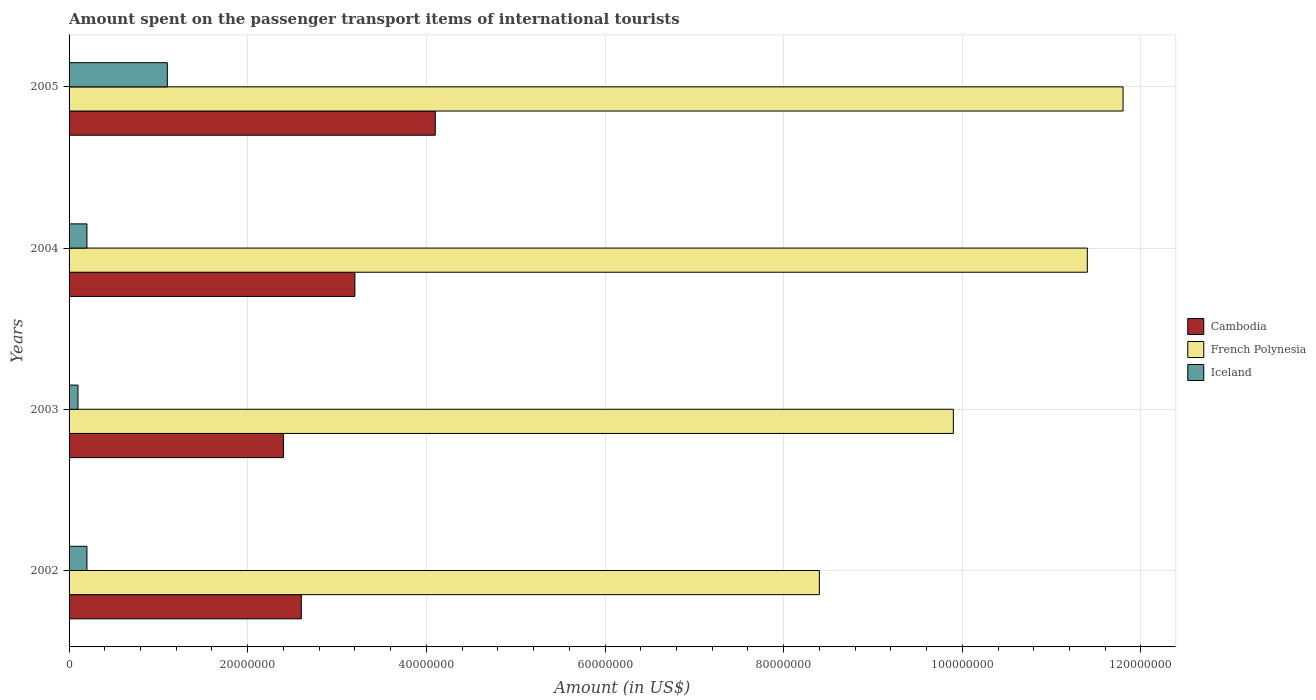How many different coloured bars are there?
Provide a short and direct response. 3. How many groups of bars are there?
Your response must be concise. 4. Are the number of bars per tick equal to the number of legend labels?
Offer a terse response. Yes. Are the number of bars on each tick of the Y-axis equal?
Ensure brevity in your answer.  Yes. In how many cases, is the number of bars for a given year not equal to the number of legend labels?
Ensure brevity in your answer.  0. What is the amount spent on the passenger transport items of international tourists in French Polynesia in 2002?
Give a very brief answer. 8.40e+07. Across all years, what is the maximum amount spent on the passenger transport items of international tourists in French Polynesia?
Provide a succinct answer. 1.18e+08. Across all years, what is the minimum amount spent on the passenger transport items of international tourists in Cambodia?
Ensure brevity in your answer.  2.40e+07. In which year was the amount spent on the passenger transport items of international tourists in French Polynesia minimum?
Your answer should be very brief. 2002. What is the total amount spent on the passenger transport items of international tourists in French Polynesia in the graph?
Your response must be concise. 4.15e+08. What is the difference between the amount spent on the passenger transport items of international tourists in Cambodia in 2002 and that in 2005?
Make the answer very short. -1.50e+07. What is the difference between the amount spent on the passenger transport items of international tourists in Iceland in 2003 and the amount spent on the passenger transport items of international tourists in French Polynesia in 2002?
Offer a terse response. -8.30e+07. What is the average amount spent on the passenger transport items of international tourists in French Polynesia per year?
Provide a succinct answer. 1.04e+08. In the year 2005, what is the difference between the amount spent on the passenger transport items of international tourists in Iceland and amount spent on the passenger transport items of international tourists in Cambodia?
Your response must be concise. -3.00e+07. What is the ratio of the amount spent on the passenger transport items of international tourists in French Polynesia in 2002 to that in 2003?
Keep it short and to the point. 0.85. What is the difference between the highest and the second highest amount spent on the passenger transport items of international tourists in Iceland?
Make the answer very short. 9.00e+06. What is the difference between the highest and the lowest amount spent on the passenger transport items of international tourists in Iceland?
Offer a very short reply. 1.00e+07. What does the 2nd bar from the top in 2003 represents?
Provide a succinct answer. French Polynesia. What does the 1st bar from the bottom in 2004 represents?
Ensure brevity in your answer.  Cambodia. Is it the case that in every year, the sum of the amount spent on the passenger transport items of international tourists in Iceland and amount spent on the passenger transport items of international tourists in Cambodia is greater than the amount spent on the passenger transport items of international tourists in French Polynesia?
Provide a succinct answer. No. Are all the bars in the graph horizontal?
Your answer should be compact. Yes. How many years are there in the graph?
Your response must be concise. 4. What is the difference between two consecutive major ticks on the X-axis?
Your answer should be very brief. 2.00e+07. Are the values on the major ticks of X-axis written in scientific E-notation?
Offer a terse response. No. Does the graph contain grids?
Give a very brief answer. Yes. Where does the legend appear in the graph?
Offer a very short reply. Center right. How are the legend labels stacked?
Offer a very short reply. Vertical. What is the title of the graph?
Offer a very short reply. Amount spent on the passenger transport items of international tourists. Does "India" appear as one of the legend labels in the graph?
Make the answer very short. No. What is the label or title of the X-axis?
Give a very brief answer. Amount (in US$). What is the label or title of the Y-axis?
Give a very brief answer. Years. What is the Amount (in US$) in Cambodia in 2002?
Provide a short and direct response. 2.60e+07. What is the Amount (in US$) of French Polynesia in 2002?
Make the answer very short. 8.40e+07. What is the Amount (in US$) in Cambodia in 2003?
Make the answer very short. 2.40e+07. What is the Amount (in US$) in French Polynesia in 2003?
Provide a short and direct response. 9.90e+07. What is the Amount (in US$) of Cambodia in 2004?
Provide a succinct answer. 3.20e+07. What is the Amount (in US$) of French Polynesia in 2004?
Give a very brief answer. 1.14e+08. What is the Amount (in US$) of Iceland in 2004?
Give a very brief answer. 2.00e+06. What is the Amount (in US$) in Cambodia in 2005?
Ensure brevity in your answer.  4.10e+07. What is the Amount (in US$) of French Polynesia in 2005?
Make the answer very short. 1.18e+08. What is the Amount (in US$) of Iceland in 2005?
Your answer should be very brief. 1.10e+07. Across all years, what is the maximum Amount (in US$) of Cambodia?
Ensure brevity in your answer.  4.10e+07. Across all years, what is the maximum Amount (in US$) of French Polynesia?
Offer a very short reply. 1.18e+08. Across all years, what is the maximum Amount (in US$) in Iceland?
Your response must be concise. 1.10e+07. Across all years, what is the minimum Amount (in US$) of Cambodia?
Provide a succinct answer. 2.40e+07. Across all years, what is the minimum Amount (in US$) in French Polynesia?
Provide a short and direct response. 8.40e+07. Across all years, what is the minimum Amount (in US$) of Iceland?
Give a very brief answer. 1.00e+06. What is the total Amount (in US$) of Cambodia in the graph?
Offer a very short reply. 1.23e+08. What is the total Amount (in US$) of French Polynesia in the graph?
Offer a very short reply. 4.15e+08. What is the total Amount (in US$) in Iceland in the graph?
Make the answer very short. 1.60e+07. What is the difference between the Amount (in US$) of French Polynesia in 2002 and that in 2003?
Your answer should be very brief. -1.50e+07. What is the difference between the Amount (in US$) in Cambodia in 2002 and that in 2004?
Offer a very short reply. -6.00e+06. What is the difference between the Amount (in US$) in French Polynesia in 2002 and that in 2004?
Provide a short and direct response. -3.00e+07. What is the difference between the Amount (in US$) of Iceland in 2002 and that in 2004?
Keep it short and to the point. 0. What is the difference between the Amount (in US$) in Cambodia in 2002 and that in 2005?
Your answer should be very brief. -1.50e+07. What is the difference between the Amount (in US$) of French Polynesia in 2002 and that in 2005?
Your answer should be compact. -3.40e+07. What is the difference between the Amount (in US$) in Iceland in 2002 and that in 2005?
Your answer should be compact. -9.00e+06. What is the difference between the Amount (in US$) of Cambodia in 2003 and that in 2004?
Your answer should be compact. -8.00e+06. What is the difference between the Amount (in US$) of French Polynesia in 2003 and that in 2004?
Offer a very short reply. -1.50e+07. What is the difference between the Amount (in US$) of Iceland in 2003 and that in 2004?
Provide a short and direct response. -1.00e+06. What is the difference between the Amount (in US$) in Cambodia in 2003 and that in 2005?
Your answer should be very brief. -1.70e+07. What is the difference between the Amount (in US$) of French Polynesia in 2003 and that in 2005?
Your response must be concise. -1.90e+07. What is the difference between the Amount (in US$) in Iceland in 2003 and that in 2005?
Offer a terse response. -1.00e+07. What is the difference between the Amount (in US$) of Cambodia in 2004 and that in 2005?
Keep it short and to the point. -9.00e+06. What is the difference between the Amount (in US$) of Iceland in 2004 and that in 2005?
Offer a very short reply. -9.00e+06. What is the difference between the Amount (in US$) of Cambodia in 2002 and the Amount (in US$) of French Polynesia in 2003?
Offer a terse response. -7.30e+07. What is the difference between the Amount (in US$) of Cambodia in 2002 and the Amount (in US$) of Iceland in 2003?
Provide a succinct answer. 2.50e+07. What is the difference between the Amount (in US$) of French Polynesia in 2002 and the Amount (in US$) of Iceland in 2003?
Keep it short and to the point. 8.30e+07. What is the difference between the Amount (in US$) in Cambodia in 2002 and the Amount (in US$) in French Polynesia in 2004?
Offer a very short reply. -8.80e+07. What is the difference between the Amount (in US$) in Cambodia in 2002 and the Amount (in US$) in Iceland in 2004?
Make the answer very short. 2.40e+07. What is the difference between the Amount (in US$) of French Polynesia in 2002 and the Amount (in US$) of Iceland in 2004?
Give a very brief answer. 8.20e+07. What is the difference between the Amount (in US$) in Cambodia in 2002 and the Amount (in US$) in French Polynesia in 2005?
Ensure brevity in your answer.  -9.20e+07. What is the difference between the Amount (in US$) of Cambodia in 2002 and the Amount (in US$) of Iceland in 2005?
Offer a terse response. 1.50e+07. What is the difference between the Amount (in US$) in French Polynesia in 2002 and the Amount (in US$) in Iceland in 2005?
Provide a short and direct response. 7.30e+07. What is the difference between the Amount (in US$) in Cambodia in 2003 and the Amount (in US$) in French Polynesia in 2004?
Provide a succinct answer. -9.00e+07. What is the difference between the Amount (in US$) of Cambodia in 2003 and the Amount (in US$) of Iceland in 2004?
Keep it short and to the point. 2.20e+07. What is the difference between the Amount (in US$) of French Polynesia in 2003 and the Amount (in US$) of Iceland in 2004?
Offer a terse response. 9.70e+07. What is the difference between the Amount (in US$) of Cambodia in 2003 and the Amount (in US$) of French Polynesia in 2005?
Ensure brevity in your answer.  -9.40e+07. What is the difference between the Amount (in US$) of Cambodia in 2003 and the Amount (in US$) of Iceland in 2005?
Your response must be concise. 1.30e+07. What is the difference between the Amount (in US$) of French Polynesia in 2003 and the Amount (in US$) of Iceland in 2005?
Give a very brief answer. 8.80e+07. What is the difference between the Amount (in US$) of Cambodia in 2004 and the Amount (in US$) of French Polynesia in 2005?
Make the answer very short. -8.60e+07. What is the difference between the Amount (in US$) of Cambodia in 2004 and the Amount (in US$) of Iceland in 2005?
Give a very brief answer. 2.10e+07. What is the difference between the Amount (in US$) of French Polynesia in 2004 and the Amount (in US$) of Iceland in 2005?
Ensure brevity in your answer.  1.03e+08. What is the average Amount (in US$) in Cambodia per year?
Provide a succinct answer. 3.08e+07. What is the average Amount (in US$) in French Polynesia per year?
Provide a succinct answer. 1.04e+08. In the year 2002, what is the difference between the Amount (in US$) in Cambodia and Amount (in US$) in French Polynesia?
Keep it short and to the point. -5.80e+07. In the year 2002, what is the difference between the Amount (in US$) of Cambodia and Amount (in US$) of Iceland?
Offer a terse response. 2.40e+07. In the year 2002, what is the difference between the Amount (in US$) in French Polynesia and Amount (in US$) in Iceland?
Your answer should be very brief. 8.20e+07. In the year 2003, what is the difference between the Amount (in US$) in Cambodia and Amount (in US$) in French Polynesia?
Give a very brief answer. -7.50e+07. In the year 2003, what is the difference between the Amount (in US$) in Cambodia and Amount (in US$) in Iceland?
Offer a very short reply. 2.30e+07. In the year 2003, what is the difference between the Amount (in US$) in French Polynesia and Amount (in US$) in Iceland?
Keep it short and to the point. 9.80e+07. In the year 2004, what is the difference between the Amount (in US$) of Cambodia and Amount (in US$) of French Polynesia?
Give a very brief answer. -8.20e+07. In the year 2004, what is the difference between the Amount (in US$) of Cambodia and Amount (in US$) of Iceland?
Ensure brevity in your answer.  3.00e+07. In the year 2004, what is the difference between the Amount (in US$) of French Polynesia and Amount (in US$) of Iceland?
Offer a terse response. 1.12e+08. In the year 2005, what is the difference between the Amount (in US$) in Cambodia and Amount (in US$) in French Polynesia?
Your answer should be very brief. -7.70e+07. In the year 2005, what is the difference between the Amount (in US$) in Cambodia and Amount (in US$) in Iceland?
Offer a very short reply. 3.00e+07. In the year 2005, what is the difference between the Amount (in US$) of French Polynesia and Amount (in US$) of Iceland?
Make the answer very short. 1.07e+08. What is the ratio of the Amount (in US$) in French Polynesia in 2002 to that in 2003?
Make the answer very short. 0.85. What is the ratio of the Amount (in US$) in Iceland in 2002 to that in 2003?
Your answer should be compact. 2. What is the ratio of the Amount (in US$) of Cambodia in 2002 to that in 2004?
Give a very brief answer. 0.81. What is the ratio of the Amount (in US$) in French Polynesia in 2002 to that in 2004?
Provide a short and direct response. 0.74. What is the ratio of the Amount (in US$) in Cambodia in 2002 to that in 2005?
Your answer should be compact. 0.63. What is the ratio of the Amount (in US$) in French Polynesia in 2002 to that in 2005?
Your response must be concise. 0.71. What is the ratio of the Amount (in US$) of Iceland in 2002 to that in 2005?
Provide a short and direct response. 0.18. What is the ratio of the Amount (in US$) of French Polynesia in 2003 to that in 2004?
Offer a terse response. 0.87. What is the ratio of the Amount (in US$) of Iceland in 2003 to that in 2004?
Give a very brief answer. 0.5. What is the ratio of the Amount (in US$) of Cambodia in 2003 to that in 2005?
Offer a terse response. 0.59. What is the ratio of the Amount (in US$) of French Polynesia in 2003 to that in 2005?
Make the answer very short. 0.84. What is the ratio of the Amount (in US$) in Iceland in 2003 to that in 2005?
Your answer should be very brief. 0.09. What is the ratio of the Amount (in US$) in Cambodia in 2004 to that in 2005?
Offer a terse response. 0.78. What is the ratio of the Amount (in US$) of French Polynesia in 2004 to that in 2005?
Offer a terse response. 0.97. What is the ratio of the Amount (in US$) of Iceland in 2004 to that in 2005?
Offer a terse response. 0.18. What is the difference between the highest and the second highest Amount (in US$) of Cambodia?
Ensure brevity in your answer.  9.00e+06. What is the difference between the highest and the second highest Amount (in US$) in Iceland?
Provide a succinct answer. 9.00e+06. What is the difference between the highest and the lowest Amount (in US$) of Cambodia?
Your answer should be very brief. 1.70e+07. What is the difference between the highest and the lowest Amount (in US$) in French Polynesia?
Provide a succinct answer. 3.40e+07. What is the difference between the highest and the lowest Amount (in US$) in Iceland?
Make the answer very short. 1.00e+07. 